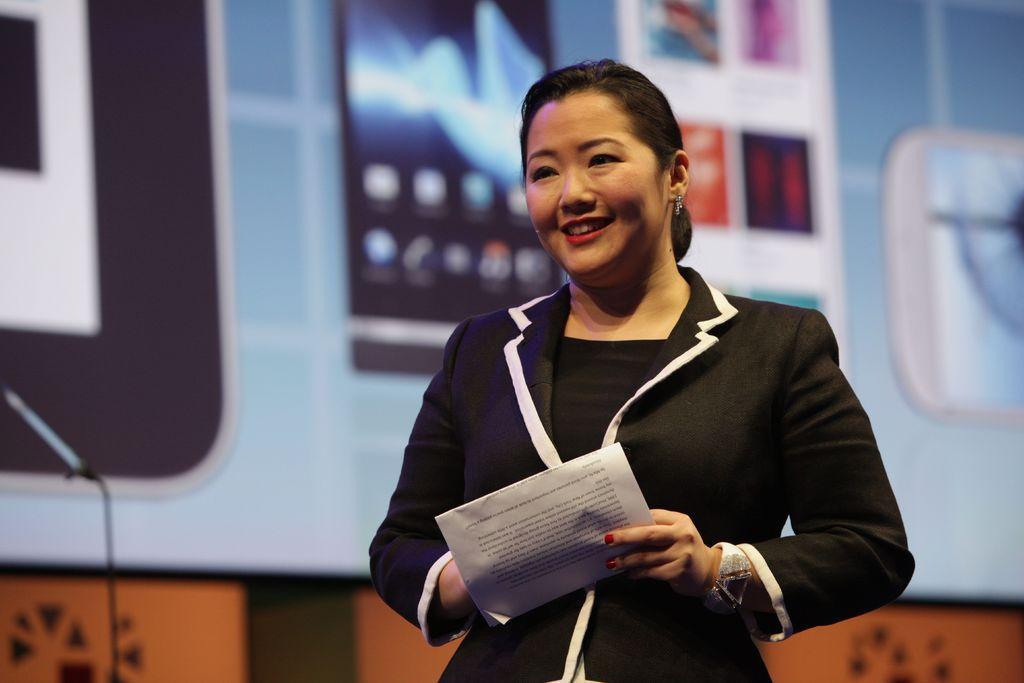Describe this image in one or two sentences. The woman in the middle of the picture wearing black dress is holding papers in her hands and she is smiling. Behind her, we see a brown color wall and behind that, we see a board in white color with some posters pasted on it. 